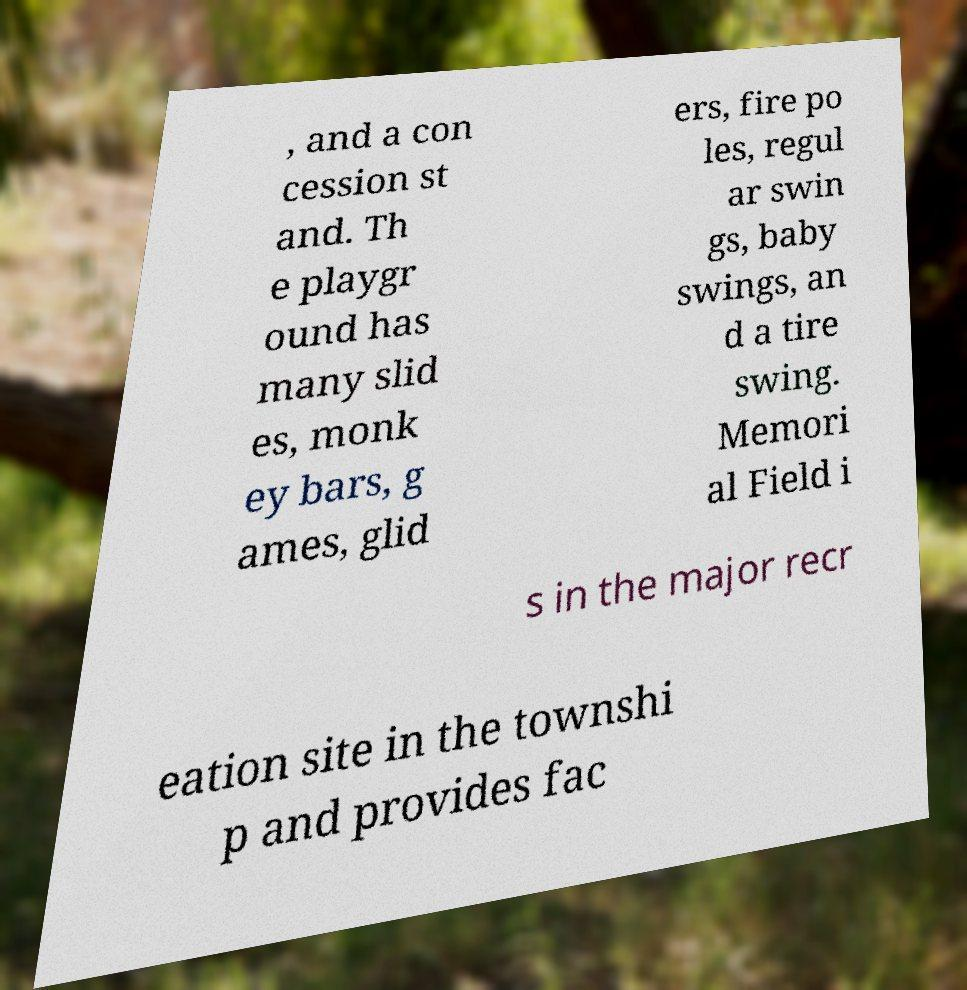Please read and relay the text visible in this image. What does it say? , and a con cession st and. Th e playgr ound has many slid es, monk ey bars, g ames, glid ers, fire po les, regul ar swin gs, baby swings, an d a tire swing. Memori al Field i s in the major recr eation site in the townshi p and provides fac 